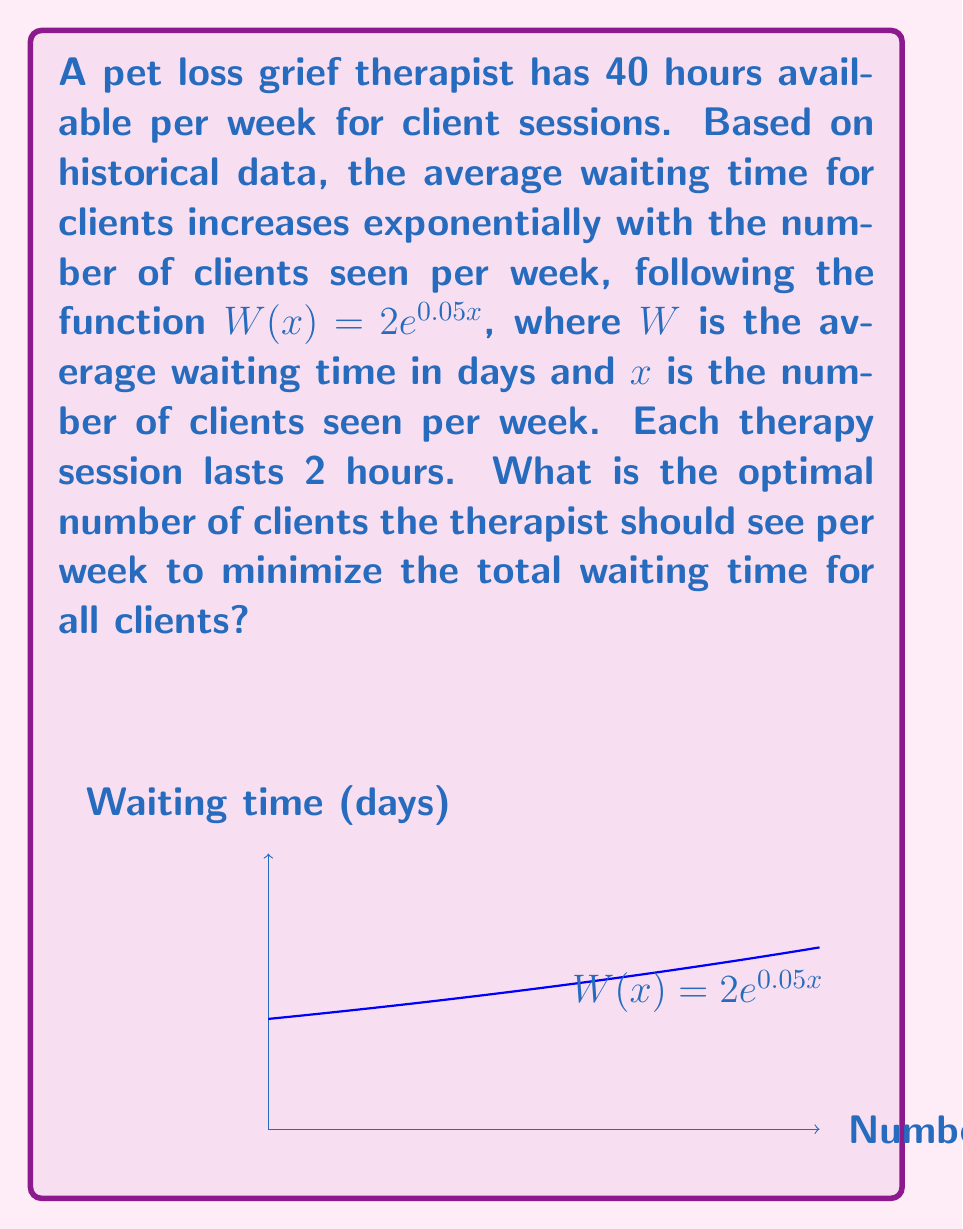Provide a solution to this math problem. To solve this optimization problem, we need to follow these steps:

1) First, let's define our objective function. We want to minimize the total waiting time for all clients. This is given by:

   $T(x) = xW(x) = x(2e^{0.05x})$

   where $x$ is the number of clients and $W(x)$ is the average waiting time per client.

2) To find the minimum of this function, we need to differentiate $T(x)$ with respect to $x$ and set it to zero:

   $\frac{dT}{dx} = 2e^{0.05x} + x(2e^{0.05x})(0.05) = 2e^{0.05x}(1 + 0.05x)$

3) Setting this equal to zero:

   $2e^{0.05x}(1 + 0.05x) = 0$

4) Since $e^{0.05x}$ is always positive, this equation is satisfied when:

   $1 + 0.05x = 0$

5) Solving for $x$:

   $0.05x = -1$
   $x = -20$

6) However, $x$ cannot be negative as it represents the number of clients. This means that the function $T(x)$ doesn't have a minimum in the positive domain.

7) Given the constraint that each session lasts 2 hours and the therapist has 40 hours available per week, the maximum number of clients that can be seen is:

   $x_{max} = 40 / 2 = 20$ clients per week

8) Since $T(x)$ is increasing for all positive $x$, the minimum total waiting time will occur at the smallest possible positive value of $x$, which is 1.

Therefore, to minimize the total waiting time, the therapist should see 1 client per week. However, this is impractical and doesn't utilize the therapist's available time. In practice, the therapist would likely choose to see the maximum number of clients (20) to help as many people as possible, even though this doesn't minimize the total waiting time.
Answer: 1 client per week (theoretically); 20 clients per week (practically) 